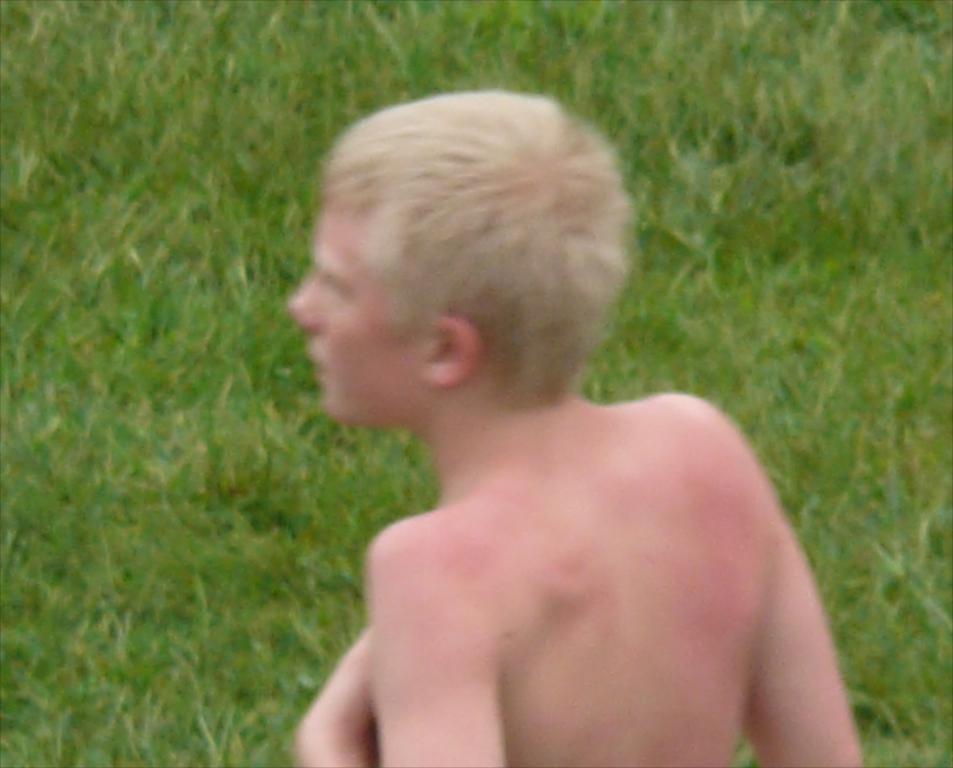Could you give a brief overview of what you see in this image? In this picture there is a boy in the center of the image and there is grassland in the image. 